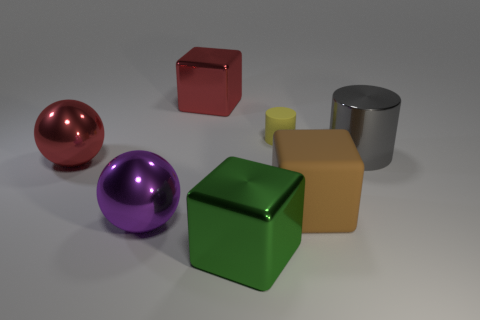Add 1 small brown shiny objects. How many objects exist? 8 Subtract all balls. How many objects are left? 5 Subtract 1 red spheres. How many objects are left? 6 Subtract all small matte objects. Subtract all yellow rubber cylinders. How many objects are left? 5 Add 6 purple balls. How many purple balls are left? 7 Add 4 matte objects. How many matte objects exist? 6 